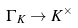<formula> <loc_0><loc_0><loc_500><loc_500>\Gamma _ { \, K } \to K ^ { \times }</formula> 